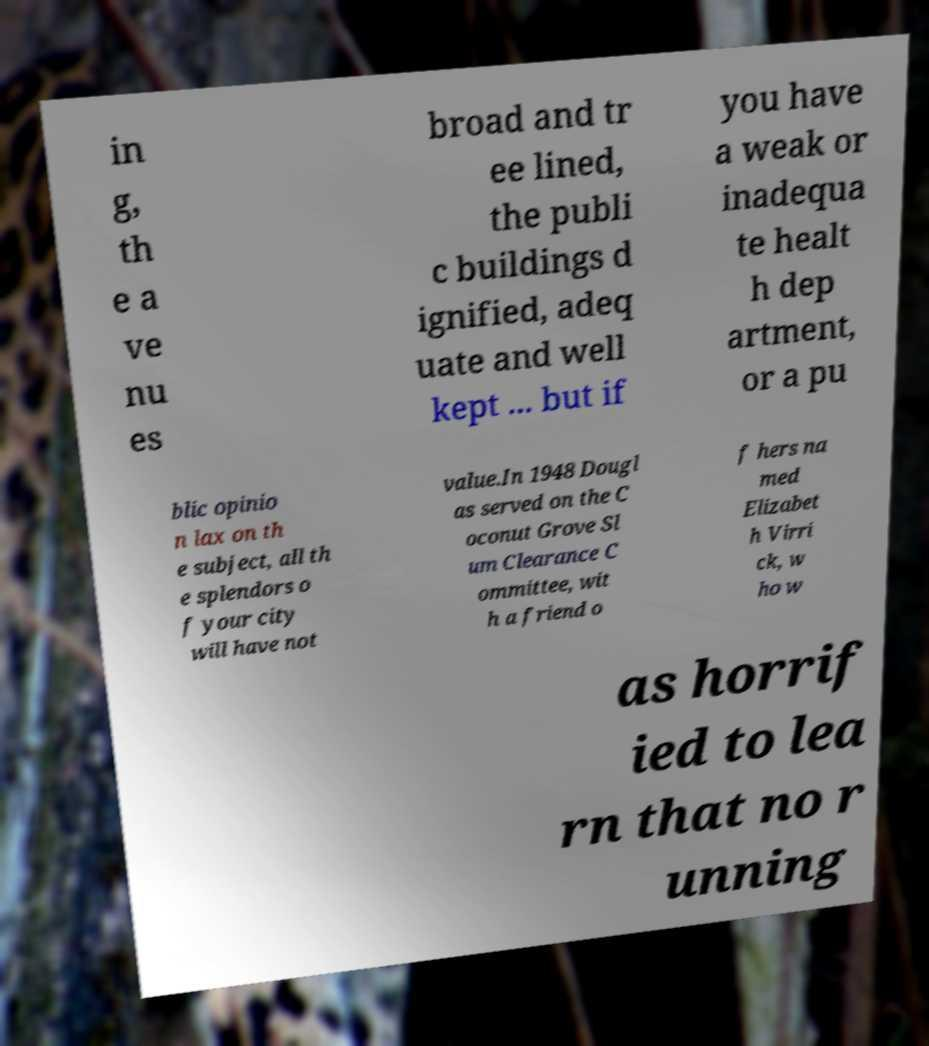Can you read and provide the text displayed in the image?This photo seems to have some interesting text. Can you extract and type it out for me? in g, th e a ve nu es broad and tr ee lined, the publi c buildings d ignified, adeq uate and well kept ... but if you have a weak or inadequa te healt h dep artment, or a pu blic opinio n lax on th e subject, all th e splendors o f your city will have not value.In 1948 Dougl as served on the C oconut Grove Sl um Clearance C ommittee, wit h a friend o f hers na med Elizabet h Virri ck, w ho w as horrif ied to lea rn that no r unning 